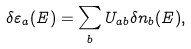<formula> <loc_0><loc_0><loc_500><loc_500>\delta \varepsilon _ { a } ( E ) = \sum _ { b } U _ { a b } \delta n _ { b } ( E ) ,</formula> 